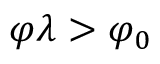<formula> <loc_0><loc_0><loc_500><loc_500>\varphi \lambda > \varphi _ { 0 }</formula> 